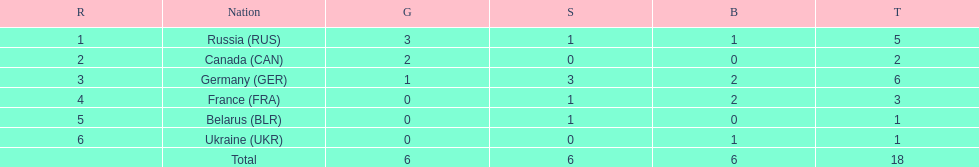How many silver medals did belarus win? 1. 